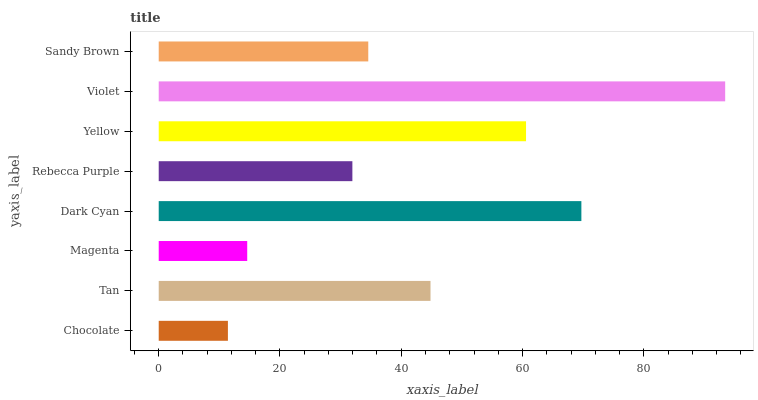Is Chocolate the minimum?
Answer yes or no. Yes. Is Violet the maximum?
Answer yes or no. Yes. Is Tan the minimum?
Answer yes or no. No. Is Tan the maximum?
Answer yes or no. No. Is Tan greater than Chocolate?
Answer yes or no. Yes. Is Chocolate less than Tan?
Answer yes or no. Yes. Is Chocolate greater than Tan?
Answer yes or no. No. Is Tan less than Chocolate?
Answer yes or no. No. Is Tan the high median?
Answer yes or no. Yes. Is Sandy Brown the low median?
Answer yes or no. Yes. Is Magenta the high median?
Answer yes or no. No. Is Rebecca Purple the low median?
Answer yes or no. No. 